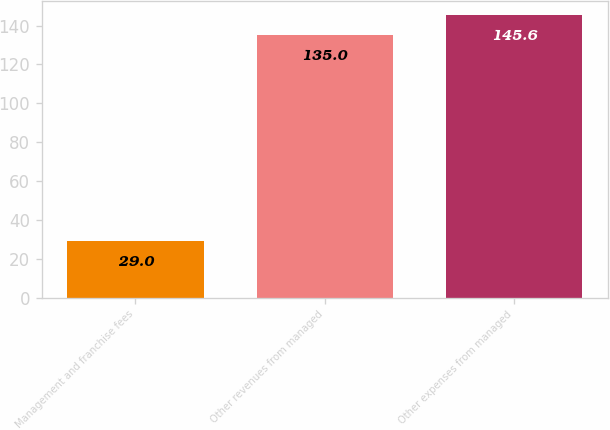Convert chart. <chart><loc_0><loc_0><loc_500><loc_500><bar_chart><fcel>Management and franchise fees<fcel>Other revenues from managed<fcel>Other expenses from managed<nl><fcel>29<fcel>135<fcel>145.6<nl></chart> 